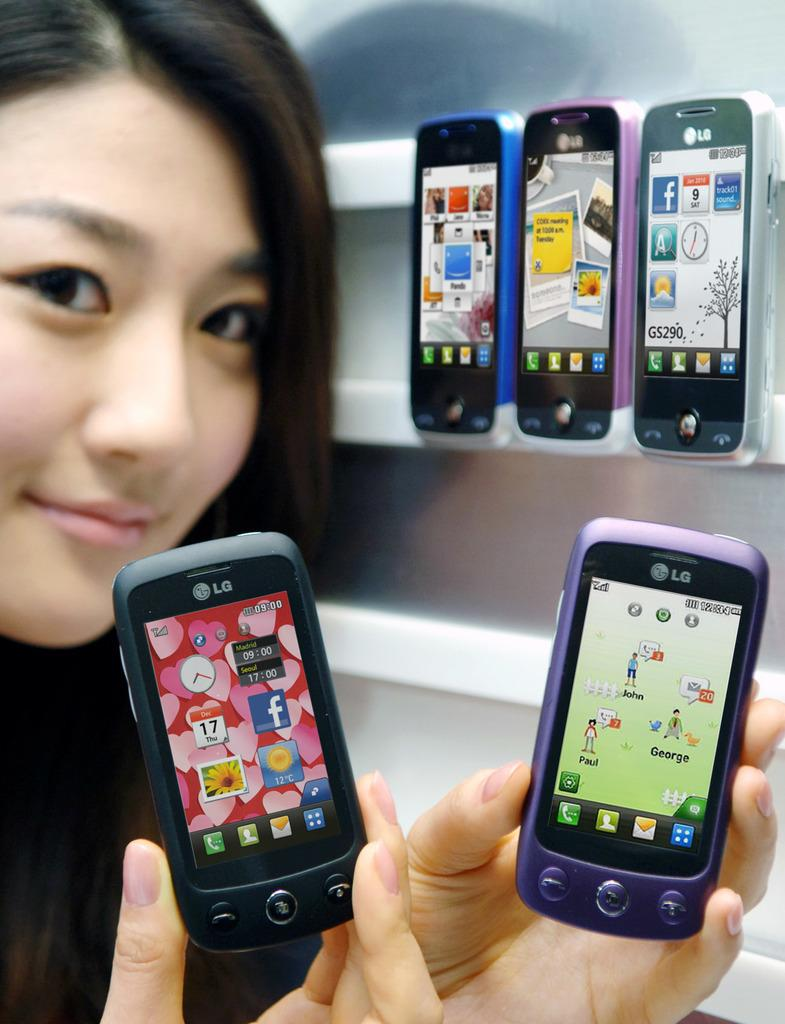<image>
Share a concise interpretation of the image provided. asian women holding two small lg play phones 